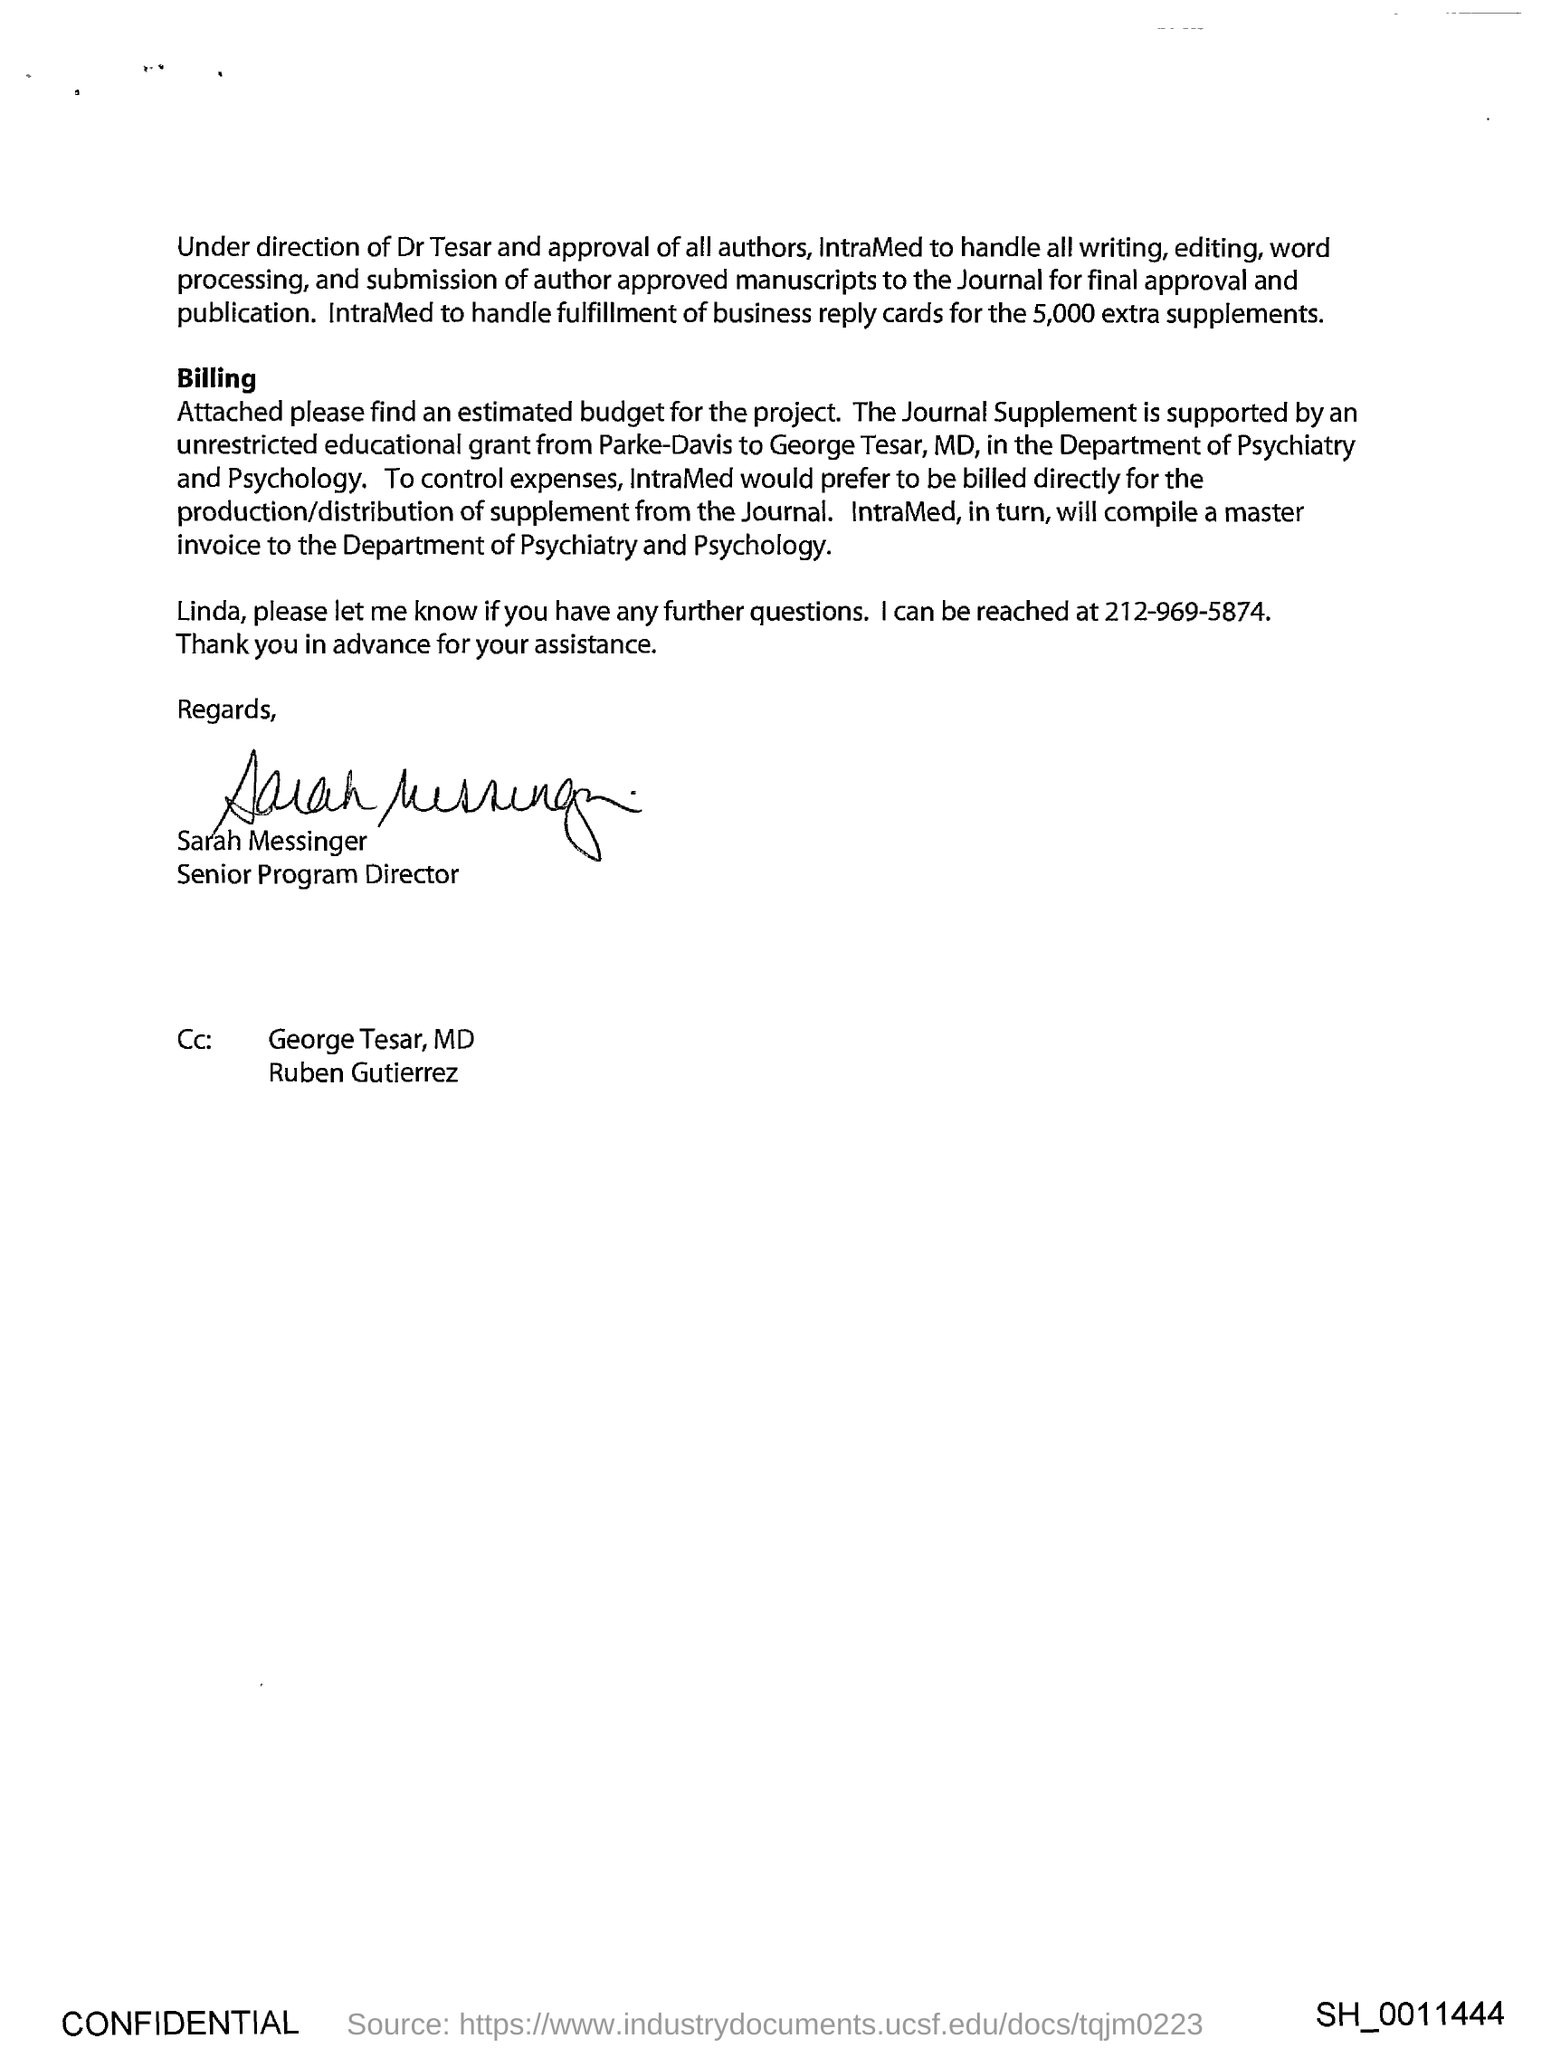Who is this letter from?
Provide a short and direct response. Sarah Messinger. 